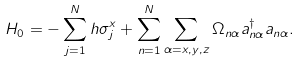Convert formula to latex. <formula><loc_0><loc_0><loc_500><loc_500>H _ { 0 } = - \sum _ { j = 1 } ^ { N } h \sigma ^ { x } _ { j } + \sum _ { n = 1 } ^ { N } \sum _ { \alpha = x , y , z } \Omega _ { n \alpha } a ^ { \dagger } _ { n \alpha } a _ { n \alpha } .</formula> 